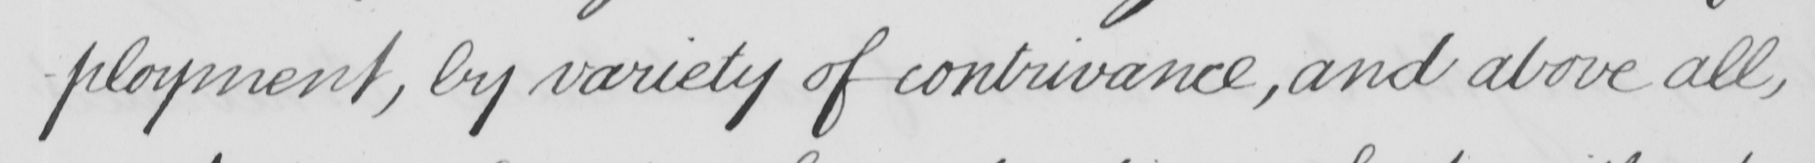Please transcribe the handwritten text in this image. - ployment , by variety of contrivance , and above all , 